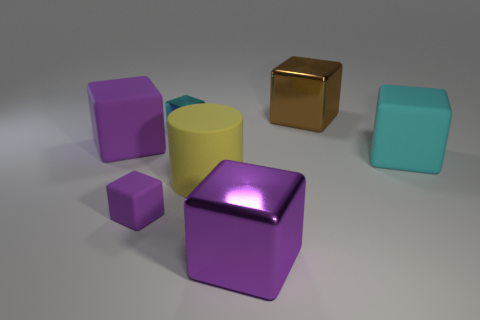How many purple blocks must be subtracted to get 1 purple blocks? 2 Subtract all brown cylinders. How many purple cubes are left? 3 Subtract all brown blocks. How many blocks are left? 5 Subtract all big matte cubes. How many cubes are left? 4 Subtract all green cubes. Subtract all green spheres. How many cubes are left? 6 Add 3 yellow shiny blocks. How many objects exist? 10 Subtract all cubes. How many objects are left? 1 Subtract all large brown metal cubes. Subtract all large objects. How many objects are left? 1 Add 5 brown objects. How many brown objects are left? 6 Add 3 small purple blocks. How many small purple blocks exist? 4 